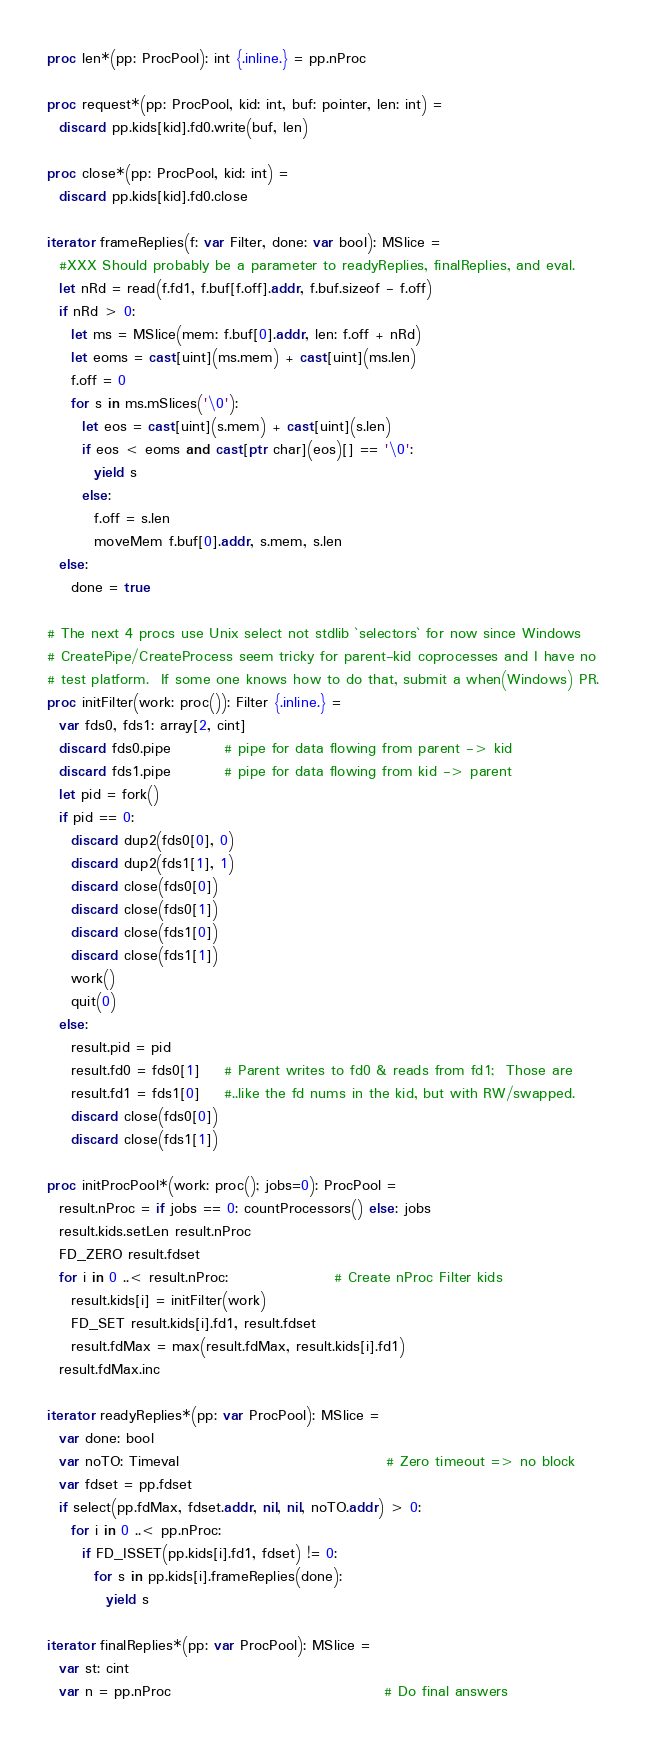Convert code to text. <code><loc_0><loc_0><loc_500><loc_500><_Nim_>proc len*(pp: ProcPool): int {.inline.} = pp.nProc

proc request*(pp: ProcPool, kid: int, buf: pointer, len: int) =
  discard pp.kids[kid].fd0.write(buf, len)

proc close*(pp: ProcPool, kid: int) =
  discard pp.kids[kid].fd0.close

iterator frameReplies(f: var Filter, done: var bool): MSlice =
  #XXX Should probably be a parameter to readyReplies, finalReplies, and eval.
  let nRd = read(f.fd1, f.buf[f.off].addr, f.buf.sizeof - f.off)
  if nRd > 0:
    let ms = MSlice(mem: f.buf[0].addr, len: f.off + nRd)
    let eoms = cast[uint](ms.mem) + cast[uint](ms.len)
    f.off = 0
    for s in ms.mSlices('\0'):
      let eos = cast[uint](s.mem) + cast[uint](s.len)
      if eos < eoms and cast[ptr char](eos)[] == '\0':
        yield s
      else:
        f.off = s.len
        moveMem f.buf[0].addr, s.mem, s.len
  else:
    done = true

# The next 4 procs use Unix select not stdlib `selectors` for now since Windows
# CreatePipe/CreateProcess seem tricky for parent-kid coprocesses and I have no
# test platform.  If some one knows how to do that, submit a when(Windows) PR.
proc initFilter(work: proc()): Filter {.inline.} =
  var fds0, fds1: array[2, cint]
  discard fds0.pipe         # pipe for data flowing from parent -> kid
  discard fds1.pipe         # pipe for data flowing from kid -> parent
  let pid = fork()
  if pid == 0:
    discard dup2(fds0[0], 0)
    discard dup2(fds1[1], 1)
    discard close(fds0[0])
    discard close(fds0[1])
    discard close(fds1[0])
    discard close(fds1[1])
    work()
    quit(0)
  else:
    result.pid = pid
    result.fd0 = fds0[1]    # Parent writes to fd0 & reads from fd1;  Those are
    result.fd1 = fds1[0]    #..like the fd nums in the kid, but with RW/swapped.
    discard close(fds0[0])
    discard close(fds1[1])

proc initProcPool*(work: proc(); jobs=0): ProcPool =
  result.nProc = if jobs == 0: countProcessors() else: jobs
  result.kids.setLen result.nProc
  FD_ZERO result.fdset
  for i in 0 ..< result.nProc:                  # Create nProc Filter kids
    result.kids[i] = initFilter(work)
    FD_SET result.kids[i].fd1, result.fdset
    result.fdMax = max(result.fdMax, result.kids[i].fd1)
  result.fdMax.inc

iterator readyReplies*(pp: var ProcPool): MSlice =
  var done: bool
  var noTO: Timeval                                   # Zero timeout => no block
  var fdset = pp.fdset
  if select(pp.fdMax, fdset.addr, nil, nil, noTO.addr) > 0:
    for i in 0 ..< pp.nProc:
      if FD_ISSET(pp.kids[i].fd1, fdset) != 0:
        for s in pp.kids[i].frameReplies(done):
          yield s

iterator finalReplies*(pp: var ProcPool): MSlice =
  var st: cint
  var n = pp.nProc                                    # Do final answers</code> 